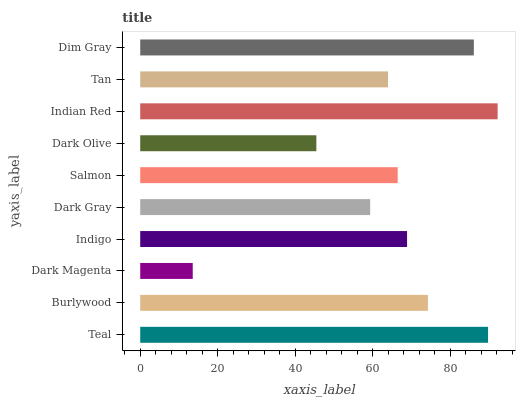Is Dark Magenta the minimum?
Answer yes or no. Yes. Is Indian Red the maximum?
Answer yes or no. Yes. Is Burlywood the minimum?
Answer yes or no. No. Is Burlywood the maximum?
Answer yes or no. No. Is Teal greater than Burlywood?
Answer yes or no. Yes. Is Burlywood less than Teal?
Answer yes or no. Yes. Is Burlywood greater than Teal?
Answer yes or no. No. Is Teal less than Burlywood?
Answer yes or no. No. Is Indigo the high median?
Answer yes or no. Yes. Is Salmon the low median?
Answer yes or no. Yes. Is Dark Magenta the high median?
Answer yes or no. No. Is Dim Gray the low median?
Answer yes or no. No. 